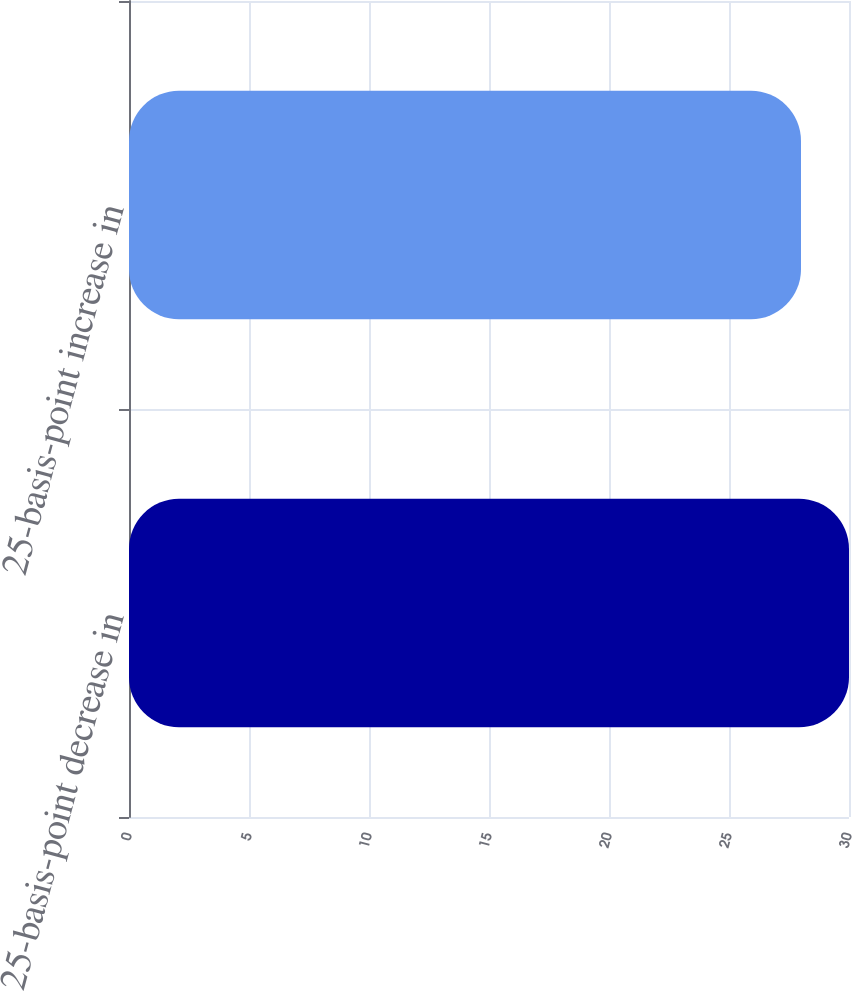<chart> <loc_0><loc_0><loc_500><loc_500><bar_chart><fcel>25-basis-point decrease in<fcel>25-basis-point increase in<nl><fcel>30<fcel>28<nl></chart> 